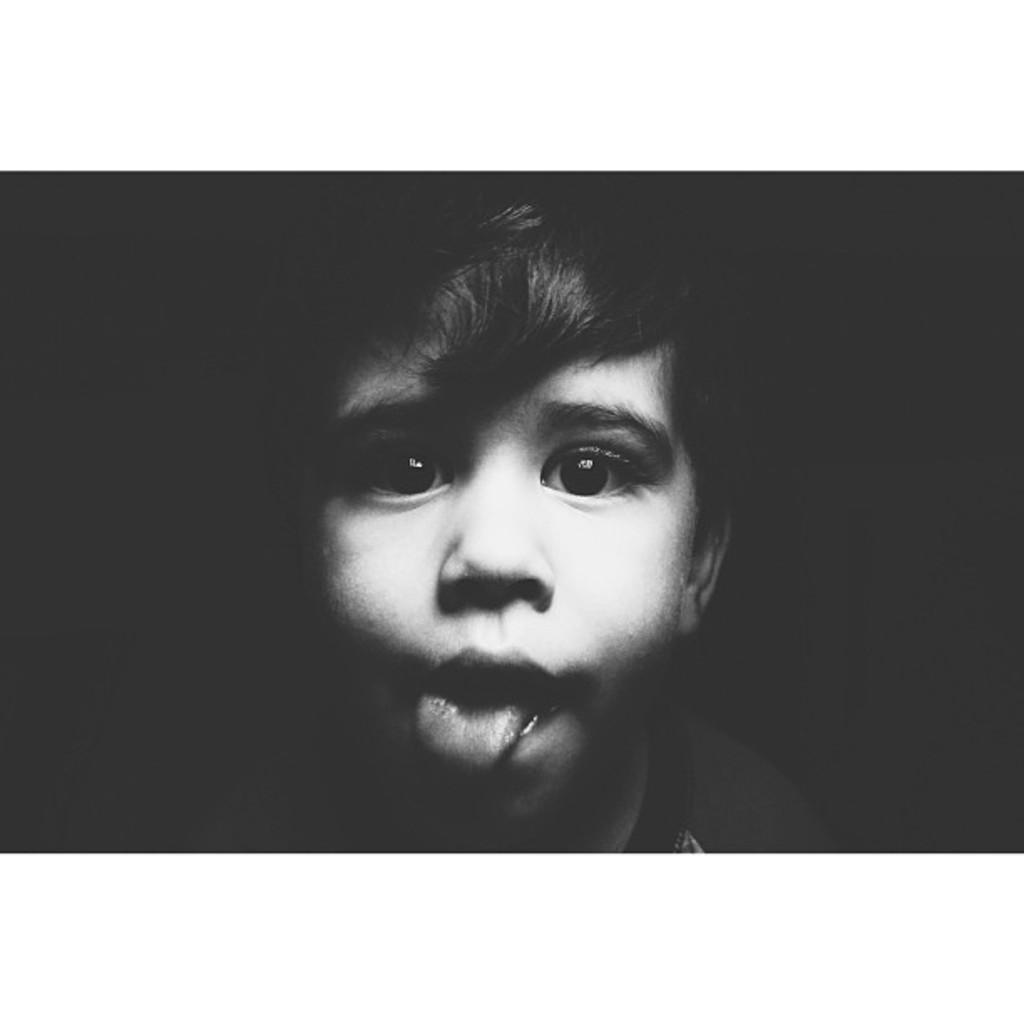What is the main subject of the image? The main subject of the image is a child. Can you describe the background of the image? The background of the image is dark. What type of income can be seen in the image? There is no income present in the image; it features a child in a dark background. What kind of machine is visible in the image? There is no machine present in the image; it only features a child in a dark background. 